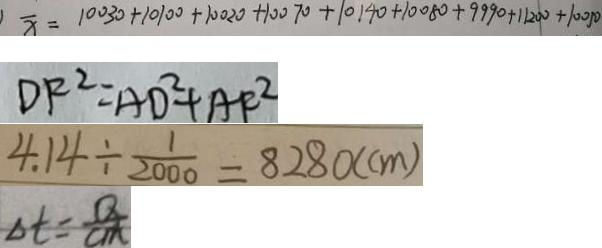<formula> <loc_0><loc_0><loc_500><loc_500>\overline { x } = 1 0 0 3 0 + 1 0 1 0 0 + 1 0 0 2 0 + 1 0 0 7 0 + 1 0 1 4 0 + 1 0 0 8 0 + 9 9 9 0 + 1 1 2 0 0 + 1 0 0 5 0 
 D F ^ { 2 } = A D ^ { 2 } + A F ^ { 2 } 
 4 . 1 4 \div \frac { 1 } { 2 0 0 0 } = 8 2 8 0 ( c m ) 
 \Delta t = \frac { Q } { c m }</formula> 